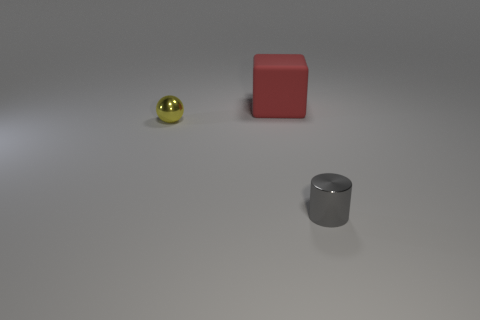Is there any other thing that has the same material as the big thing?
Make the answer very short. No. What is the size of the shiny thing on the right side of the small object behind the shiny object right of the cube?
Your answer should be compact. Small. How many other things are there of the same shape as the large red matte object?
Provide a short and direct response. 0. There is a metal object that is behind the tiny gray cylinder; does it have the same shape as the large red rubber thing behind the yellow metallic thing?
Your answer should be compact. No. What number of cylinders are rubber things or tiny things?
Offer a terse response. 1. There is a tiny object that is behind the small metallic thing in front of the small metal object to the left of the gray cylinder; what is it made of?
Your answer should be very brief. Metal. What number of other things are the same size as the shiny ball?
Your answer should be compact. 1. Is the number of matte objects that are behind the yellow ball greater than the number of small gray rubber blocks?
Keep it short and to the point. Yes. There is a metal sphere that is the same size as the gray metal thing; what is its color?
Make the answer very short. Yellow. How many tiny objects are in front of the small object left of the big thing?
Provide a succinct answer. 1. 